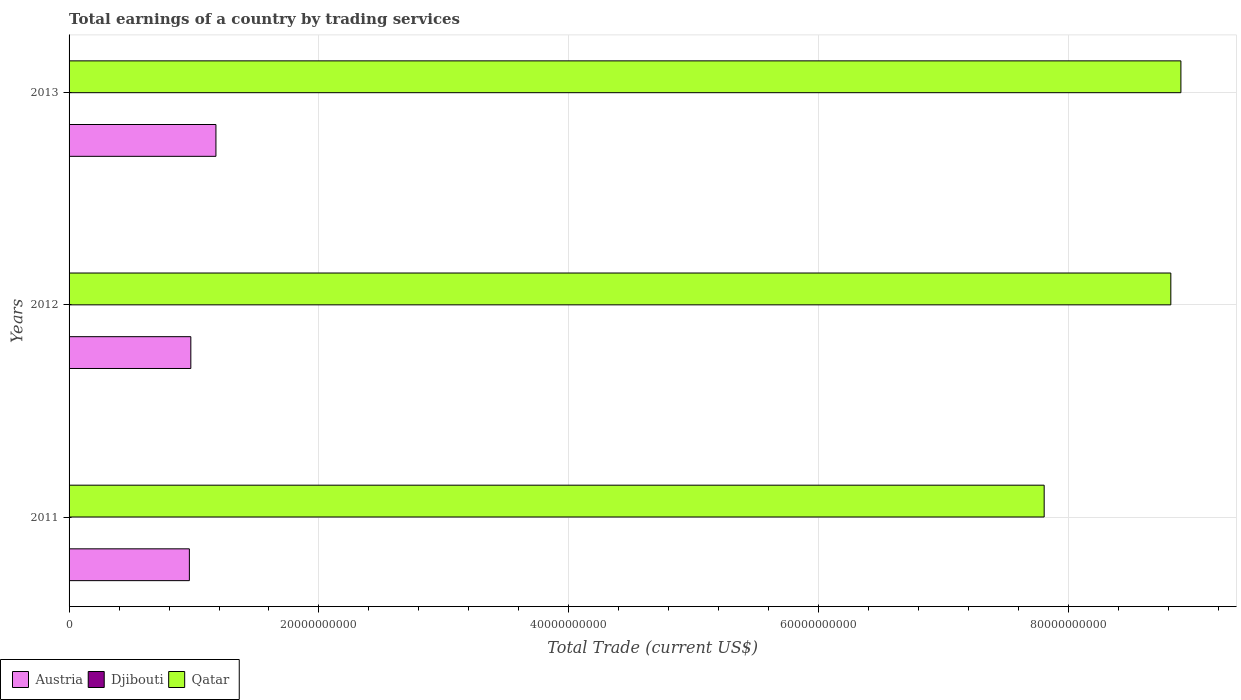How many different coloured bars are there?
Offer a very short reply. 2. How many groups of bars are there?
Your response must be concise. 3. Are the number of bars per tick equal to the number of legend labels?
Offer a terse response. No. What is the label of the 1st group of bars from the top?
Your answer should be very brief. 2013. In how many cases, is the number of bars for a given year not equal to the number of legend labels?
Offer a terse response. 3. What is the total earnings in Qatar in 2012?
Give a very brief answer. 8.82e+1. Across all years, what is the maximum total earnings in Qatar?
Provide a short and direct response. 8.90e+1. Across all years, what is the minimum total earnings in Qatar?
Your answer should be very brief. 7.80e+1. In which year was the total earnings in Austria maximum?
Your answer should be compact. 2013. What is the total total earnings in Qatar in the graph?
Provide a short and direct response. 2.55e+11. What is the difference between the total earnings in Austria in 2011 and that in 2012?
Make the answer very short. -1.16e+08. What is the difference between the total earnings in Austria in 2013 and the total earnings in Djibouti in 2012?
Your answer should be very brief. 1.18e+1. What is the average total earnings in Qatar per year?
Provide a short and direct response. 8.51e+1. In the year 2013, what is the difference between the total earnings in Austria and total earnings in Qatar?
Offer a very short reply. -7.72e+1. What is the ratio of the total earnings in Qatar in 2011 to that in 2013?
Your answer should be very brief. 0.88. What is the difference between the highest and the second highest total earnings in Qatar?
Ensure brevity in your answer.  8.06e+08. What is the difference between the highest and the lowest total earnings in Qatar?
Your answer should be very brief. 1.09e+1. Is the sum of the total earnings in Austria in 2011 and 2013 greater than the maximum total earnings in Qatar across all years?
Your answer should be very brief. No. Are all the bars in the graph horizontal?
Give a very brief answer. Yes. How many years are there in the graph?
Your answer should be very brief. 3. How many legend labels are there?
Offer a very short reply. 3. How are the legend labels stacked?
Offer a very short reply. Horizontal. What is the title of the graph?
Provide a short and direct response. Total earnings of a country by trading services. What is the label or title of the X-axis?
Give a very brief answer. Total Trade (current US$). What is the label or title of the Y-axis?
Keep it short and to the point. Years. What is the Total Trade (current US$) in Austria in 2011?
Ensure brevity in your answer.  9.63e+09. What is the Total Trade (current US$) of Qatar in 2011?
Provide a succinct answer. 7.80e+1. What is the Total Trade (current US$) in Austria in 2012?
Your response must be concise. 9.75e+09. What is the Total Trade (current US$) in Djibouti in 2012?
Offer a terse response. 0. What is the Total Trade (current US$) in Qatar in 2012?
Offer a very short reply. 8.82e+1. What is the Total Trade (current US$) in Austria in 2013?
Provide a succinct answer. 1.18e+1. What is the Total Trade (current US$) of Qatar in 2013?
Give a very brief answer. 8.90e+1. Across all years, what is the maximum Total Trade (current US$) in Austria?
Your answer should be very brief. 1.18e+1. Across all years, what is the maximum Total Trade (current US$) of Qatar?
Offer a terse response. 8.90e+1. Across all years, what is the minimum Total Trade (current US$) of Austria?
Provide a short and direct response. 9.63e+09. Across all years, what is the minimum Total Trade (current US$) of Qatar?
Provide a short and direct response. 7.80e+1. What is the total Total Trade (current US$) of Austria in the graph?
Your response must be concise. 3.11e+1. What is the total Total Trade (current US$) of Qatar in the graph?
Ensure brevity in your answer.  2.55e+11. What is the difference between the Total Trade (current US$) of Austria in 2011 and that in 2012?
Your answer should be very brief. -1.16e+08. What is the difference between the Total Trade (current US$) in Qatar in 2011 and that in 2012?
Keep it short and to the point. -1.01e+1. What is the difference between the Total Trade (current US$) of Austria in 2011 and that in 2013?
Offer a very short reply. -2.13e+09. What is the difference between the Total Trade (current US$) of Qatar in 2011 and that in 2013?
Your answer should be compact. -1.09e+1. What is the difference between the Total Trade (current US$) in Austria in 2012 and that in 2013?
Your answer should be compact. -2.01e+09. What is the difference between the Total Trade (current US$) in Qatar in 2012 and that in 2013?
Keep it short and to the point. -8.06e+08. What is the difference between the Total Trade (current US$) in Austria in 2011 and the Total Trade (current US$) in Qatar in 2012?
Your answer should be very brief. -7.86e+1. What is the difference between the Total Trade (current US$) of Austria in 2011 and the Total Trade (current US$) of Qatar in 2013?
Your answer should be compact. -7.94e+1. What is the difference between the Total Trade (current US$) in Austria in 2012 and the Total Trade (current US$) in Qatar in 2013?
Ensure brevity in your answer.  -7.92e+1. What is the average Total Trade (current US$) of Austria per year?
Provide a succinct answer. 1.04e+1. What is the average Total Trade (current US$) in Qatar per year?
Offer a terse response. 8.51e+1. In the year 2011, what is the difference between the Total Trade (current US$) of Austria and Total Trade (current US$) of Qatar?
Your answer should be very brief. -6.84e+1. In the year 2012, what is the difference between the Total Trade (current US$) of Austria and Total Trade (current US$) of Qatar?
Keep it short and to the point. -7.84e+1. In the year 2013, what is the difference between the Total Trade (current US$) in Austria and Total Trade (current US$) in Qatar?
Offer a very short reply. -7.72e+1. What is the ratio of the Total Trade (current US$) of Qatar in 2011 to that in 2012?
Ensure brevity in your answer.  0.89. What is the ratio of the Total Trade (current US$) of Austria in 2011 to that in 2013?
Ensure brevity in your answer.  0.82. What is the ratio of the Total Trade (current US$) of Qatar in 2011 to that in 2013?
Ensure brevity in your answer.  0.88. What is the ratio of the Total Trade (current US$) in Austria in 2012 to that in 2013?
Your answer should be compact. 0.83. What is the ratio of the Total Trade (current US$) of Qatar in 2012 to that in 2013?
Ensure brevity in your answer.  0.99. What is the difference between the highest and the second highest Total Trade (current US$) of Austria?
Your answer should be compact. 2.01e+09. What is the difference between the highest and the second highest Total Trade (current US$) in Qatar?
Keep it short and to the point. 8.06e+08. What is the difference between the highest and the lowest Total Trade (current US$) in Austria?
Provide a short and direct response. 2.13e+09. What is the difference between the highest and the lowest Total Trade (current US$) of Qatar?
Your answer should be compact. 1.09e+1. 